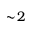<formula> <loc_0><loc_0><loc_500><loc_500>\sim \, 2</formula> 